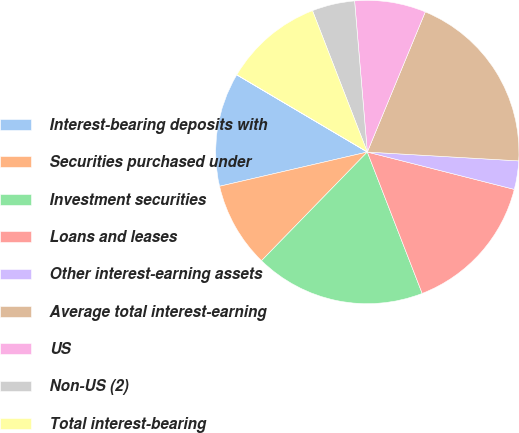Convert chart. <chart><loc_0><loc_0><loc_500><loc_500><pie_chart><fcel>Interest-bearing deposits with<fcel>Securities purchased under<fcel>Investment securities<fcel>Loans and leases<fcel>Other interest-earning assets<fcel>Average total interest-earning<fcel>US<fcel>Non-US (2)<fcel>Total interest-bearing<fcel>Securities sold under<nl><fcel>12.12%<fcel>9.09%<fcel>18.18%<fcel>15.15%<fcel>3.03%<fcel>19.69%<fcel>7.58%<fcel>4.55%<fcel>10.61%<fcel>0.01%<nl></chart> 